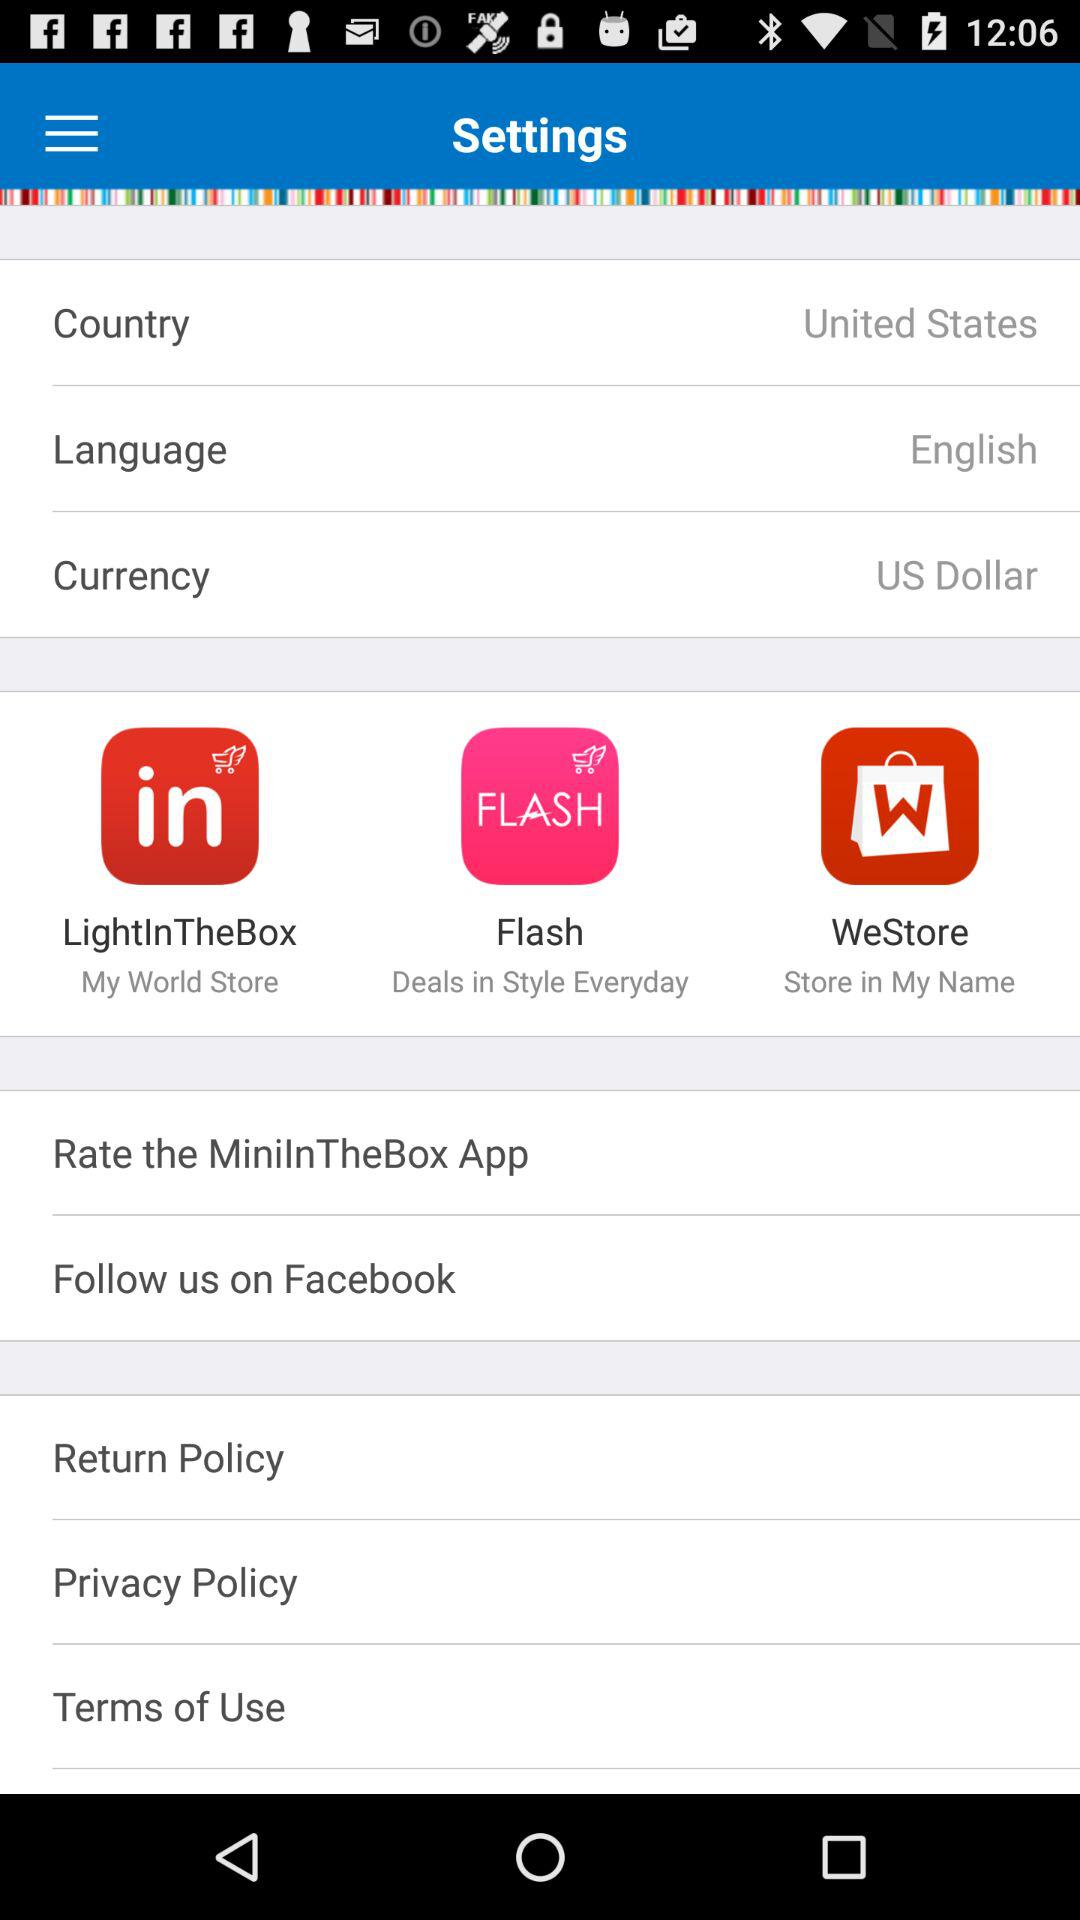Which currency is selected? The selected currency is the US dollar. 